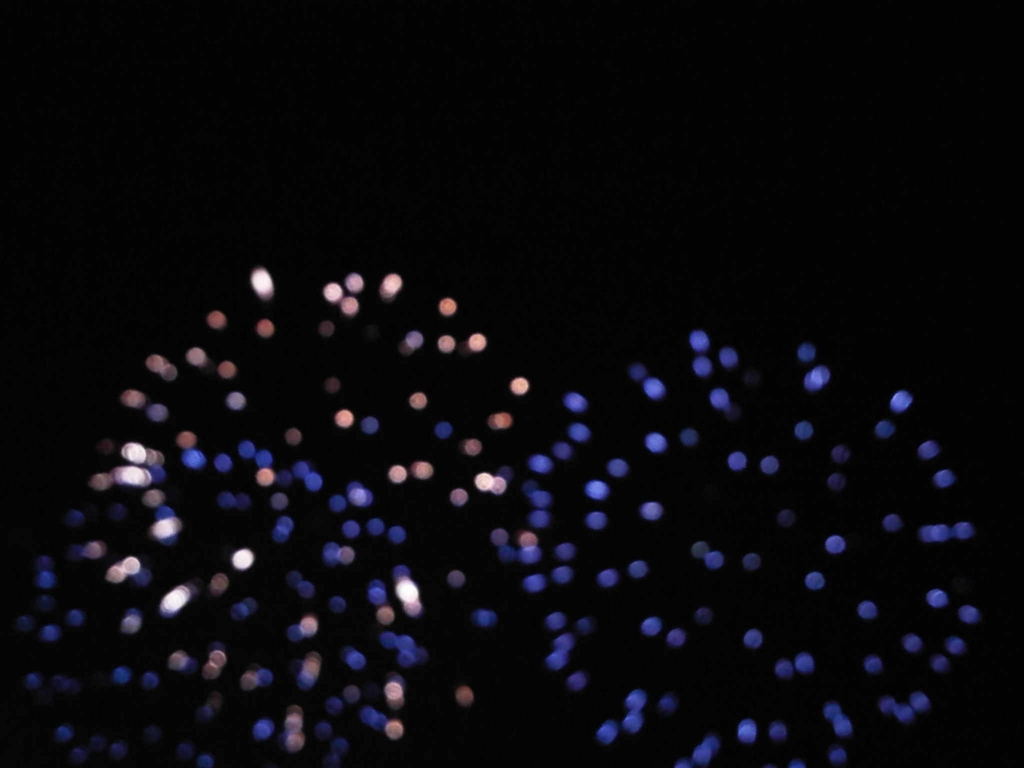What mood or atmosphere does this image convey? The image exudes a mysterious and intriguing atmosphere. The cool blue and warm white tones suggest a serene or contemplative mood, potentially evoking feelings of quietness, introspection, or even isolation. 